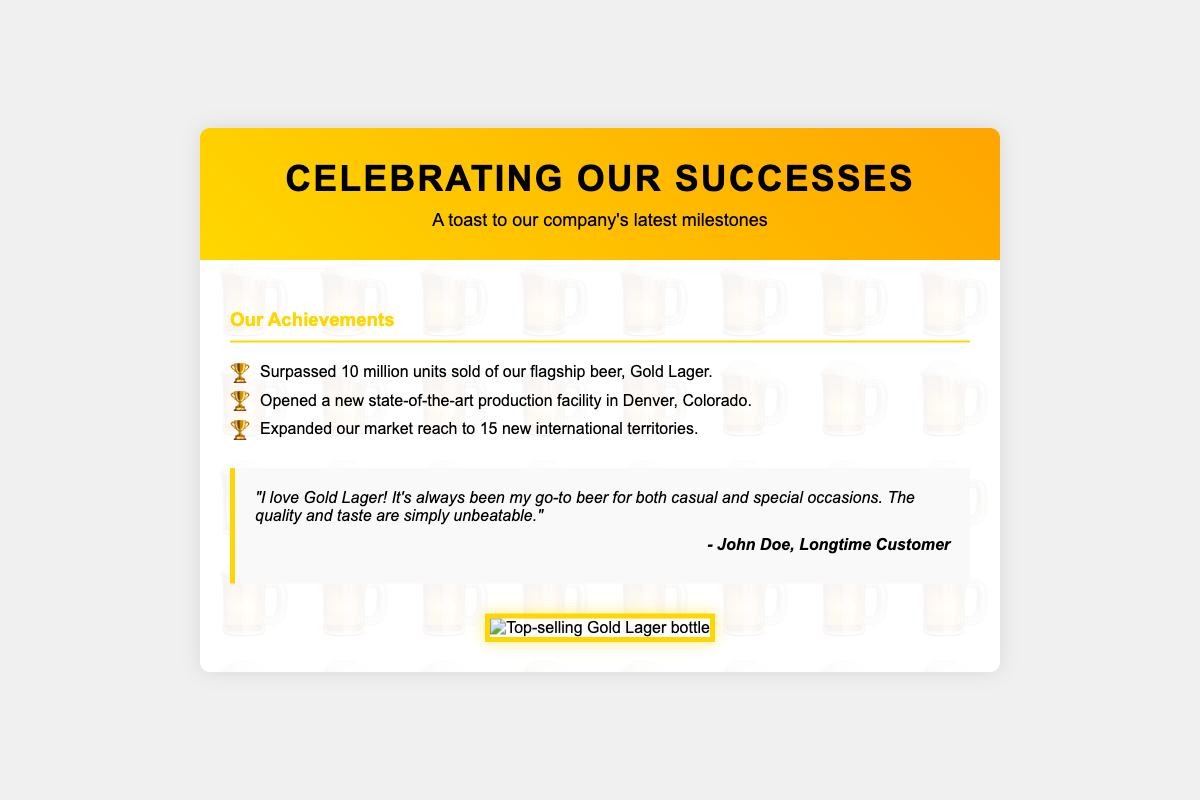What is the title of the card? The title of the card is prominently displayed in the header section of the document.
Answer: Celebrating Our Successes How many units of Gold Lager were sold? The document lists a specific achievement regarding the sales of Gold Lager in the milestones section.
Answer: 10 million Where is the new production facility located? The document mentions the location of the new facility in the milestones section.
Answer: Denver, Colorado Which beer is highlighted as the top-selling product? The document refers to a specific beer as the top-selling one in the image description.
Answer: Gold Lager Who provided the customer quote? The document includes an author's name attributed to the customer quote in the quote section.
Answer: John Doe What is the primary color theme of the card? The design elements and header suggest a particular color scheme that is evident throughout the card.
Answer: Gold What type of card is this? The context and structure suggest a specific type of card used to celebrate achievements.
Answer: Greeting card What image is included with the card? The image section describes what kind of image is presented in the document.
Answer: Top-selling Gold Lager bottle What milestone relates to international markets? The document outlines a specific achievement that includes expanding market reach.
Answer: 15 new international territories 